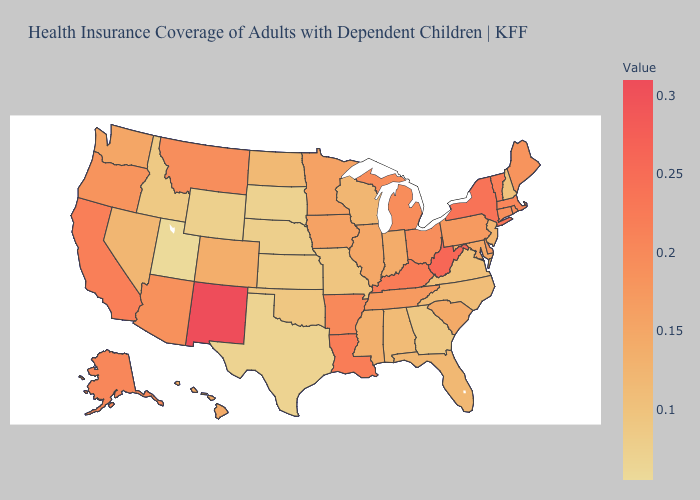Among the states that border Nevada , does Arizona have the lowest value?
Keep it brief. No. Among the states that border Delaware , which have the lowest value?
Short answer required. New Jersey. Which states have the lowest value in the USA?
Short answer required. Utah. Does Iowa have the highest value in the MidWest?
Write a very short answer. No. Which states have the lowest value in the USA?
Be succinct. Utah. 